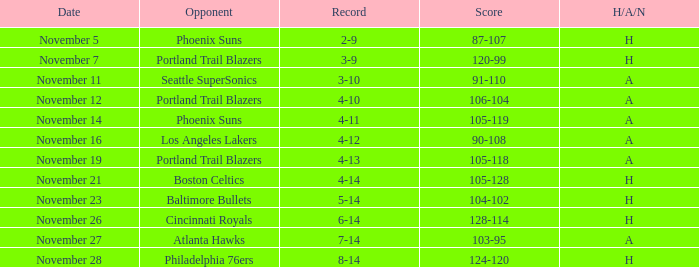On what Date was the Score 105-118 and the H/A/N A? November 19. 